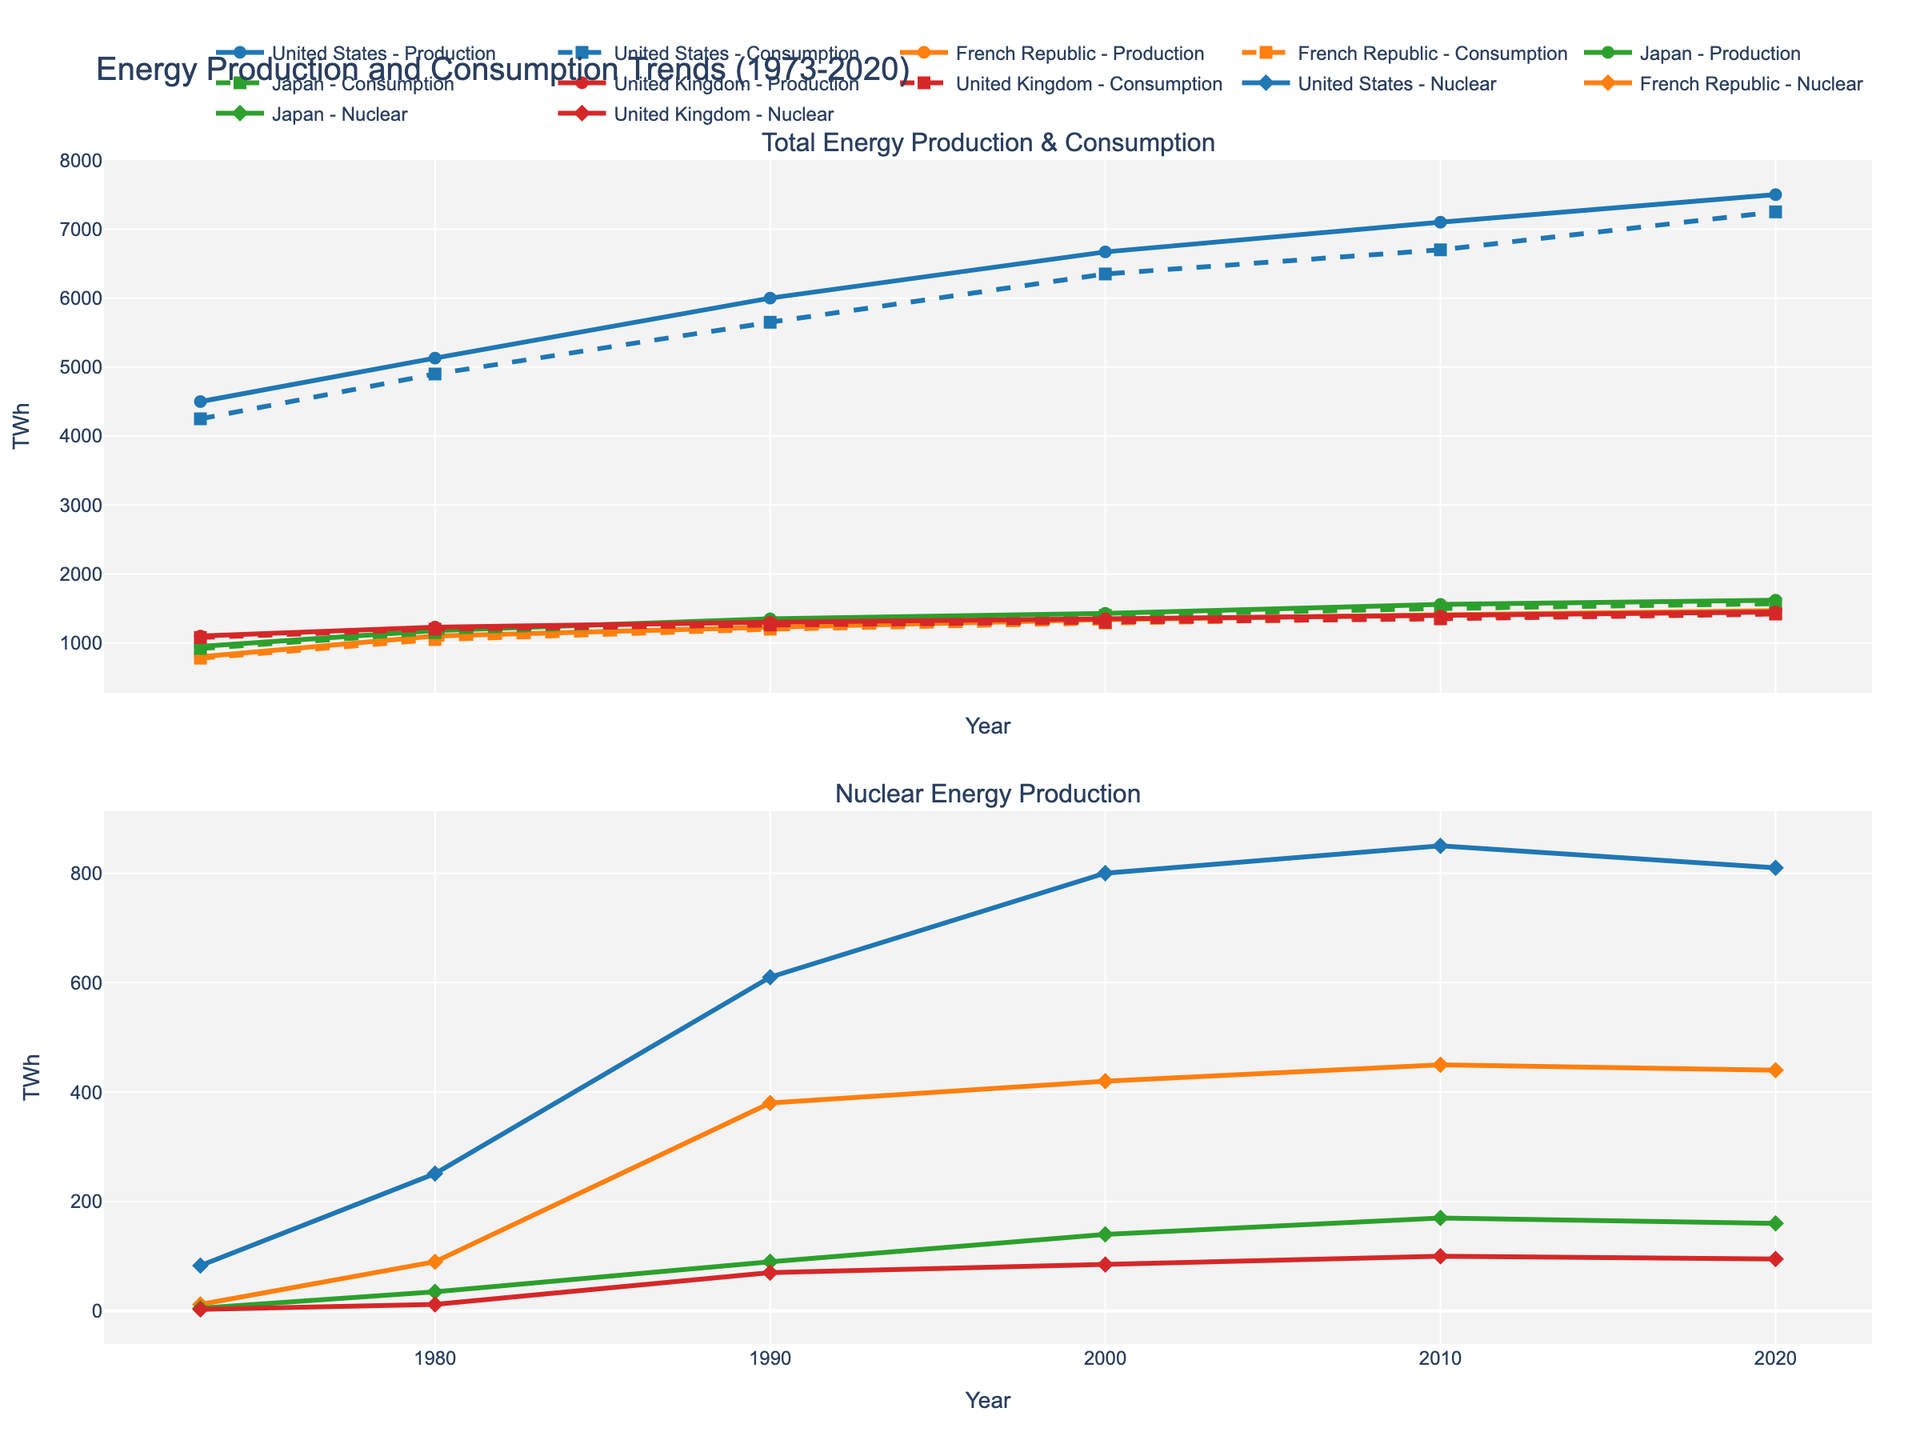What is the title of the figure? The title is usually located at the top of the figure. From the provided code, we can see the title specified in the layout.
Answer: Energy Production and Consumption Trends (1973-2020) What are the units on the y-axes of both subplots? The y-axis label is defined in the figure layout and is consistent for both subplots. It represents energy measured in TWh (terawatt-hours).
Answer: TWh Which country has the highest total energy production in 2020? By examining the data points for 2020 in the subplot for Total Energy Production & Consumption, the United States has the highest energy production.
Answer: United States How has Japan's nuclear energy production changed from 1973 to 2020? Look at the trend line for Japan in the Nuclear Energy Production subplot. We see values in 1973 (5 TWh) and 2020 (160 TWh). There is a general increase over this period.
Answer: Increased Compare the total energy consumption of the United States and the French Republic in 2010. Refer to the 2010 data points in the Total Energy Production & Consumption subplot. The United States has a consumption of 6700 TWh, while the French Republic has 1360 TWh. 6700 TWh is greater than 1360 TWh.
Answer: United States What is the difference in nuclear energy production between the United States and the French Republic in 2000? From the Nuclear Energy Production subplot, in 2000, the United States produced 800 TWh and the French Republic produced 420 TWh. The difference is 800 - 420.
Answer: 380 TWh Which year saw the highest nuclear energy production in the United States? Track the highest point on the United States' trend line in the Nuclear Energy Production subplot. The highest point (850 TWh) is in 2010.
Answer: 2010 What pattern can you observe in the total energy consumption of the United Kingdom from 1973 to 2020? Looking at the United Kingdom's trend line in the Total Energy Production & Consumption subplot, the energy consumption appears to increase gradually from 1080 TWh in 1973 to a peak around 2010 and then stabilizes.
Answer: Gradual increase followed by stabilization Compare the number of data points presented for each country. Are they all the same? Each country's trend lines in the plots represent data points for the years 1973, 1980, 1990, 2000, 2010, and 2020, making it 6 data points each.
Answer: Yes How did the nuclear energy production in the French Republic change between 1980 and 1990? From the Nuclear Energy Production subplot, the French Republic's nuclear energy production increased from 90 TWh in 1980 to 380 TWh in 1990.
Answer: Increased 